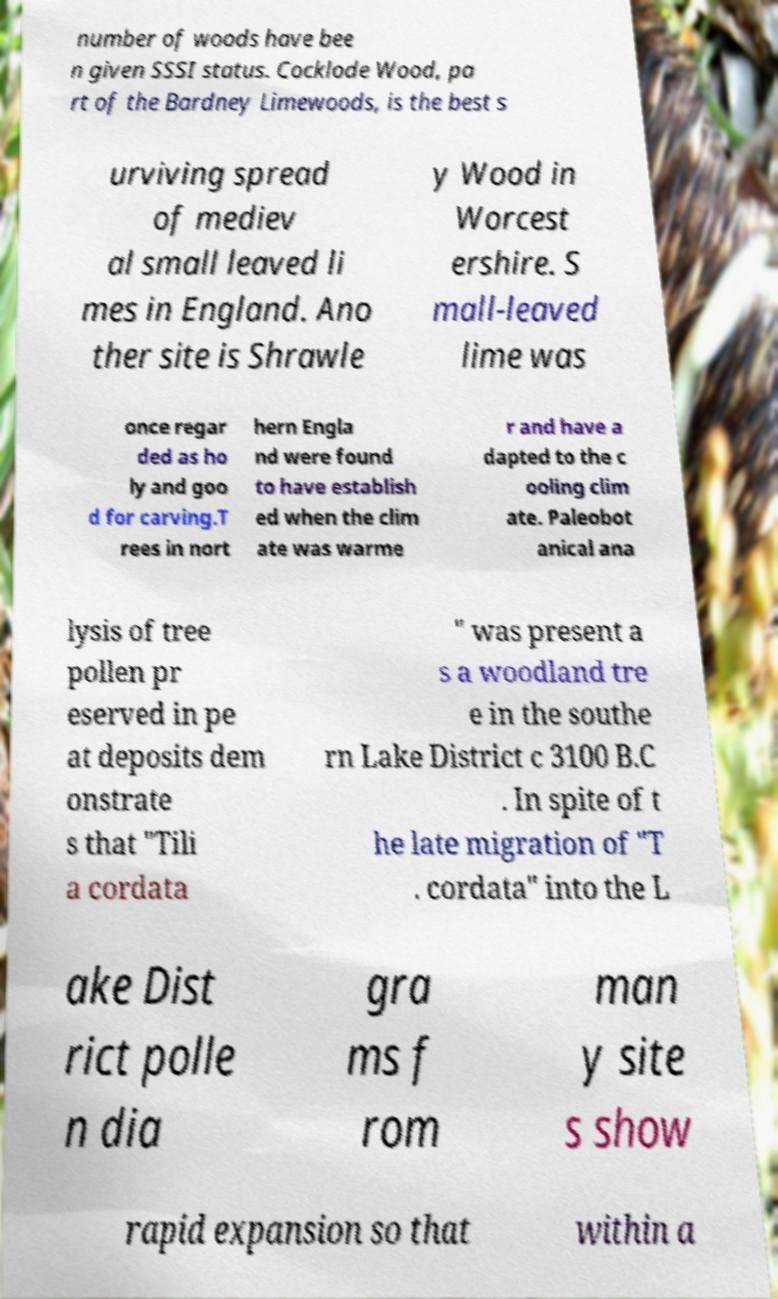Can you accurately transcribe the text from the provided image for me? number of woods have bee n given SSSI status. Cocklode Wood, pa rt of the Bardney Limewoods, is the best s urviving spread of mediev al small leaved li mes in England. Ano ther site is Shrawle y Wood in Worcest ershire. S mall-leaved lime was once regar ded as ho ly and goo d for carving.T rees in nort hern Engla nd were found to have establish ed when the clim ate was warme r and have a dapted to the c ooling clim ate. Paleobot anical ana lysis of tree pollen pr eserved in pe at deposits dem onstrate s that "Tili a cordata " was present a s a woodland tre e in the southe rn Lake District c 3100 B.C . In spite of t he late migration of "T . cordata" into the L ake Dist rict polle n dia gra ms f rom man y site s show rapid expansion so that within a 